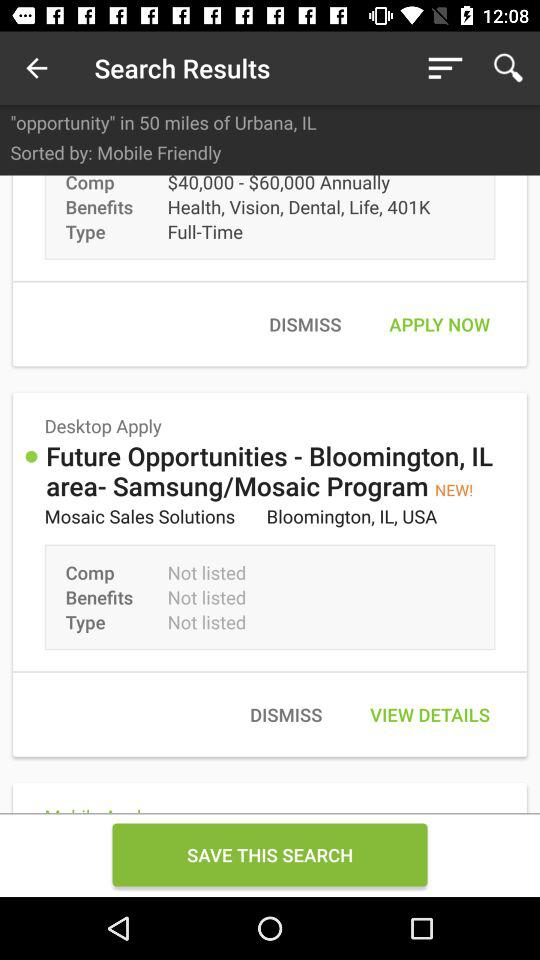What are the benefits in "Future Opportunities - Bloomington, IL area- Samsung/Mosaic Program"? The benefits in "Future Opportunities - Bloomington, IL area- Samsung/Mosaic Program" are not listed. 